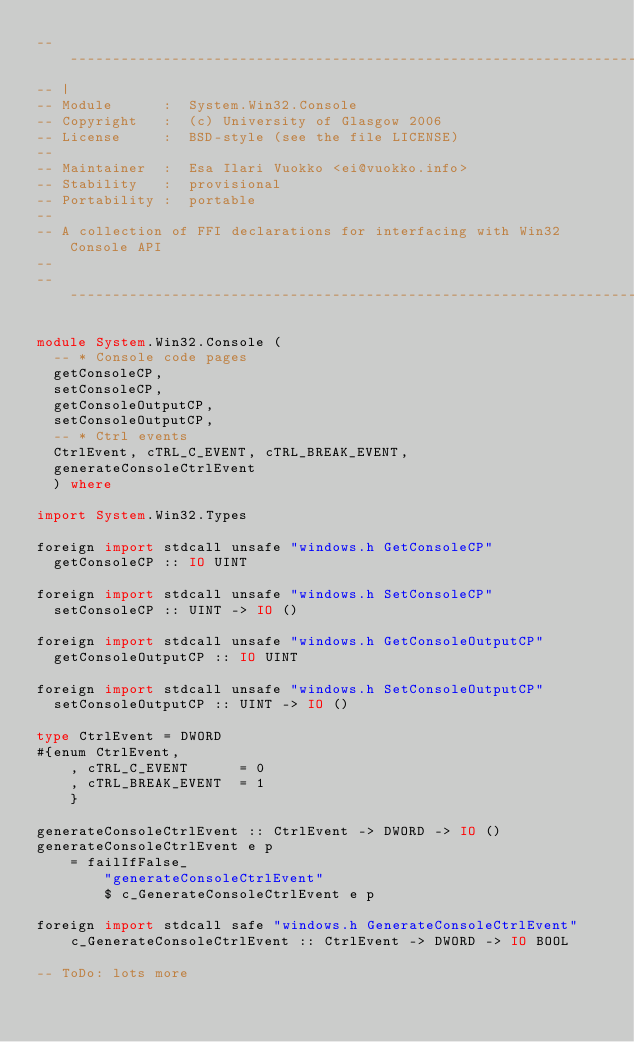Convert code to text. <code><loc_0><loc_0><loc_500><loc_500><_Haskell_>-----------------------------------------------------------------------------
-- |
-- Module      :  System.Win32.Console
-- Copyright   :  (c) University of Glasgow 2006
-- License     :  BSD-style (see the file LICENSE)
--
-- Maintainer  :  Esa Ilari Vuokko <ei@vuokko.info>
-- Stability   :  provisional
-- Portability :  portable
--
-- A collection of FFI declarations for interfacing with Win32 Console API
--
-----------------------------------------------------------------------------

module System.Win32.Console (
	-- * Console code pages
	getConsoleCP,
	setConsoleCP,
	getConsoleOutputCP,
	setConsoleOutputCP,
	-- * Ctrl events
	CtrlEvent, cTRL_C_EVENT, cTRL_BREAK_EVENT,
	generateConsoleCtrlEvent
  ) where

import System.Win32.Types

foreign import stdcall unsafe "windows.h GetConsoleCP"
	getConsoleCP :: IO UINT

foreign import stdcall unsafe "windows.h SetConsoleCP"
	setConsoleCP :: UINT -> IO ()

foreign import stdcall unsafe "windows.h GetConsoleOutputCP"
	getConsoleOutputCP :: IO UINT

foreign import stdcall unsafe "windows.h SetConsoleOutputCP"
	setConsoleOutputCP :: UINT -> IO ()

type CtrlEvent = DWORD
#{enum CtrlEvent,
    , cTRL_C_EVENT      = 0
    , cTRL_BREAK_EVENT  = 1
    }

generateConsoleCtrlEvent :: CtrlEvent -> DWORD -> IO ()
generateConsoleCtrlEvent e p
    = failIfFalse_
        "generateConsoleCtrlEvent"
        $ c_GenerateConsoleCtrlEvent e p

foreign import stdcall safe "windows.h GenerateConsoleCtrlEvent"
    c_GenerateConsoleCtrlEvent :: CtrlEvent -> DWORD -> IO BOOL

-- ToDo: lots more
</code> 